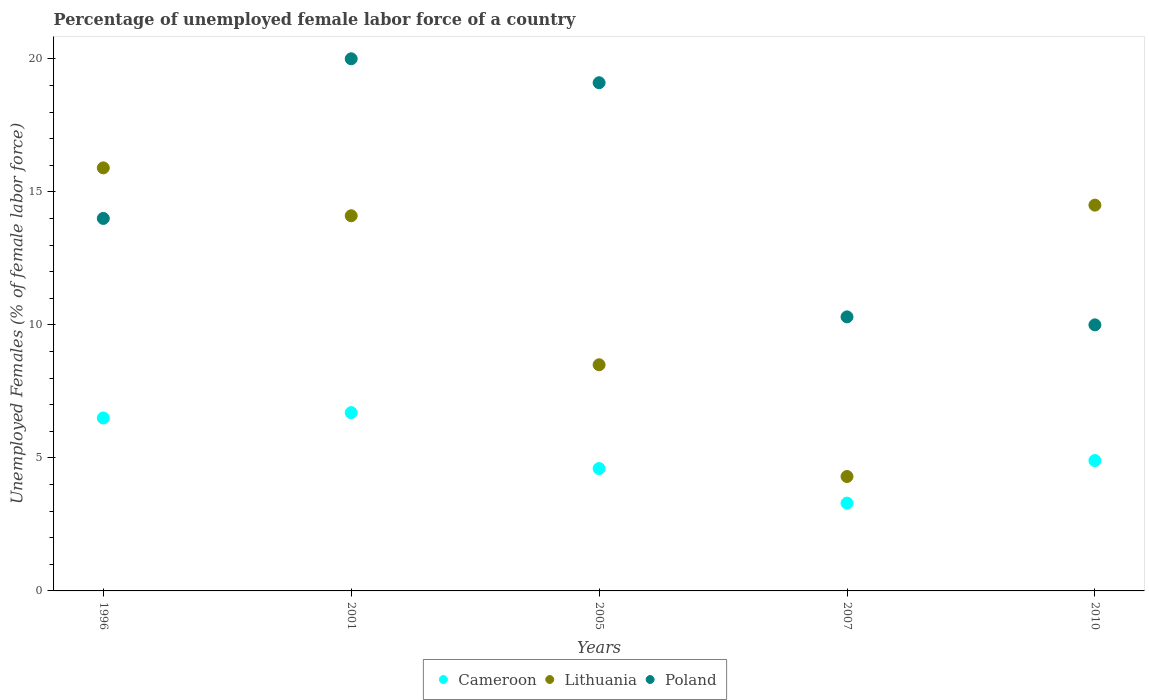How many different coloured dotlines are there?
Keep it short and to the point. 3. What is the percentage of unemployed female labor force in Poland in 1996?
Your answer should be compact. 14. Across all years, what is the maximum percentage of unemployed female labor force in Cameroon?
Keep it short and to the point. 6.7. Across all years, what is the minimum percentage of unemployed female labor force in Cameroon?
Keep it short and to the point. 3.3. In which year was the percentage of unemployed female labor force in Lithuania maximum?
Your answer should be very brief. 1996. In which year was the percentage of unemployed female labor force in Lithuania minimum?
Your answer should be very brief. 2007. What is the total percentage of unemployed female labor force in Poland in the graph?
Your response must be concise. 73.4. What is the difference between the percentage of unemployed female labor force in Poland in 1996 and that in 2007?
Provide a succinct answer. 3.7. What is the difference between the percentage of unemployed female labor force in Poland in 2005 and the percentage of unemployed female labor force in Cameroon in 2007?
Make the answer very short. 15.8. What is the average percentage of unemployed female labor force in Lithuania per year?
Your answer should be compact. 11.46. In the year 2005, what is the difference between the percentage of unemployed female labor force in Poland and percentage of unemployed female labor force in Lithuania?
Offer a very short reply. 10.6. What is the ratio of the percentage of unemployed female labor force in Lithuania in 2001 to that in 2010?
Your answer should be compact. 0.97. Is the percentage of unemployed female labor force in Poland in 2001 less than that in 2005?
Make the answer very short. No. What is the difference between the highest and the second highest percentage of unemployed female labor force in Lithuania?
Your answer should be very brief. 1.4. What is the difference between the highest and the lowest percentage of unemployed female labor force in Lithuania?
Provide a short and direct response. 11.6. In how many years, is the percentage of unemployed female labor force in Lithuania greater than the average percentage of unemployed female labor force in Lithuania taken over all years?
Your response must be concise. 3. Is the sum of the percentage of unemployed female labor force in Cameroon in 2001 and 2007 greater than the maximum percentage of unemployed female labor force in Poland across all years?
Offer a terse response. No. Is it the case that in every year, the sum of the percentage of unemployed female labor force in Poland and percentage of unemployed female labor force in Lithuania  is greater than the percentage of unemployed female labor force in Cameroon?
Your answer should be compact. Yes. Is the percentage of unemployed female labor force in Cameroon strictly greater than the percentage of unemployed female labor force in Poland over the years?
Offer a very short reply. No. How many dotlines are there?
Offer a terse response. 3. Does the graph contain any zero values?
Provide a succinct answer. No. Does the graph contain grids?
Provide a succinct answer. No. Where does the legend appear in the graph?
Offer a terse response. Bottom center. How are the legend labels stacked?
Offer a terse response. Horizontal. What is the title of the graph?
Provide a succinct answer. Percentage of unemployed female labor force of a country. What is the label or title of the X-axis?
Ensure brevity in your answer.  Years. What is the label or title of the Y-axis?
Provide a short and direct response. Unemployed Females (% of female labor force). What is the Unemployed Females (% of female labor force) in Lithuania in 1996?
Provide a short and direct response. 15.9. What is the Unemployed Females (% of female labor force) of Poland in 1996?
Provide a succinct answer. 14. What is the Unemployed Females (% of female labor force) of Cameroon in 2001?
Offer a terse response. 6.7. What is the Unemployed Females (% of female labor force) of Lithuania in 2001?
Offer a terse response. 14.1. What is the Unemployed Females (% of female labor force) in Cameroon in 2005?
Keep it short and to the point. 4.6. What is the Unemployed Females (% of female labor force) of Poland in 2005?
Make the answer very short. 19.1. What is the Unemployed Females (% of female labor force) of Cameroon in 2007?
Give a very brief answer. 3.3. What is the Unemployed Females (% of female labor force) in Lithuania in 2007?
Ensure brevity in your answer.  4.3. What is the Unemployed Females (% of female labor force) in Poland in 2007?
Provide a succinct answer. 10.3. What is the Unemployed Females (% of female labor force) of Cameroon in 2010?
Your response must be concise. 4.9. What is the Unemployed Females (% of female labor force) in Lithuania in 2010?
Your response must be concise. 14.5. What is the Unemployed Females (% of female labor force) of Poland in 2010?
Your answer should be compact. 10. Across all years, what is the maximum Unemployed Females (% of female labor force) of Cameroon?
Ensure brevity in your answer.  6.7. Across all years, what is the maximum Unemployed Females (% of female labor force) of Lithuania?
Offer a very short reply. 15.9. Across all years, what is the minimum Unemployed Females (% of female labor force) in Cameroon?
Ensure brevity in your answer.  3.3. Across all years, what is the minimum Unemployed Females (% of female labor force) in Lithuania?
Offer a terse response. 4.3. Across all years, what is the minimum Unemployed Females (% of female labor force) in Poland?
Your answer should be compact. 10. What is the total Unemployed Females (% of female labor force) in Cameroon in the graph?
Offer a terse response. 26. What is the total Unemployed Females (% of female labor force) of Lithuania in the graph?
Offer a terse response. 57.3. What is the total Unemployed Females (% of female labor force) in Poland in the graph?
Offer a very short reply. 73.4. What is the difference between the Unemployed Females (% of female labor force) of Cameroon in 1996 and that in 2001?
Keep it short and to the point. -0.2. What is the difference between the Unemployed Females (% of female labor force) in Poland in 1996 and that in 2001?
Your answer should be very brief. -6. What is the difference between the Unemployed Females (% of female labor force) in Lithuania in 1996 and that in 2005?
Give a very brief answer. 7.4. What is the difference between the Unemployed Females (% of female labor force) in Poland in 1996 and that in 2005?
Your response must be concise. -5.1. What is the difference between the Unemployed Females (% of female labor force) in Lithuania in 1996 and that in 2007?
Your answer should be compact. 11.6. What is the difference between the Unemployed Females (% of female labor force) of Poland in 1996 and that in 2007?
Ensure brevity in your answer.  3.7. What is the difference between the Unemployed Females (% of female labor force) of Cameroon in 1996 and that in 2010?
Keep it short and to the point. 1.6. What is the difference between the Unemployed Females (% of female labor force) of Lithuania in 2001 and that in 2005?
Make the answer very short. 5.6. What is the difference between the Unemployed Females (% of female labor force) in Lithuania in 2001 and that in 2010?
Offer a very short reply. -0.4. What is the difference between the Unemployed Females (% of female labor force) of Poland in 2001 and that in 2010?
Make the answer very short. 10. What is the difference between the Unemployed Females (% of female labor force) in Cameroon in 2005 and that in 2007?
Offer a terse response. 1.3. What is the difference between the Unemployed Females (% of female labor force) in Lithuania in 2005 and that in 2007?
Keep it short and to the point. 4.2. What is the difference between the Unemployed Females (% of female labor force) in Lithuania in 2005 and that in 2010?
Your answer should be very brief. -6. What is the difference between the Unemployed Females (% of female labor force) of Poland in 2005 and that in 2010?
Keep it short and to the point. 9.1. What is the difference between the Unemployed Females (% of female labor force) in Poland in 2007 and that in 2010?
Your answer should be very brief. 0.3. What is the difference between the Unemployed Females (% of female labor force) of Cameroon in 1996 and the Unemployed Females (% of female labor force) of Lithuania in 2001?
Offer a very short reply. -7.6. What is the difference between the Unemployed Females (% of female labor force) of Cameroon in 1996 and the Unemployed Females (% of female labor force) of Poland in 2001?
Ensure brevity in your answer.  -13.5. What is the difference between the Unemployed Females (% of female labor force) in Cameroon in 1996 and the Unemployed Females (% of female labor force) in Lithuania in 2005?
Make the answer very short. -2. What is the difference between the Unemployed Females (% of female labor force) of Cameroon in 1996 and the Unemployed Females (% of female labor force) of Poland in 2007?
Ensure brevity in your answer.  -3.8. What is the difference between the Unemployed Females (% of female labor force) in Lithuania in 1996 and the Unemployed Females (% of female labor force) in Poland in 2010?
Provide a short and direct response. 5.9. What is the difference between the Unemployed Females (% of female labor force) of Cameroon in 2001 and the Unemployed Females (% of female labor force) of Poland in 2007?
Ensure brevity in your answer.  -3.6. What is the difference between the Unemployed Females (% of female labor force) of Cameroon in 2001 and the Unemployed Females (% of female labor force) of Poland in 2010?
Your answer should be compact. -3.3. What is the difference between the Unemployed Females (% of female labor force) in Cameroon in 2005 and the Unemployed Females (% of female labor force) in Poland in 2007?
Provide a short and direct response. -5.7. What is the difference between the Unemployed Females (% of female labor force) in Lithuania in 2005 and the Unemployed Females (% of female labor force) in Poland in 2007?
Your response must be concise. -1.8. What is the difference between the Unemployed Females (% of female labor force) of Cameroon in 2005 and the Unemployed Females (% of female labor force) of Lithuania in 2010?
Provide a short and direct response. -9.9. What is the difference between the Unemployed Females (% of female labor force) of Lithuania in 2007 and the Unemployed Females (% of female labor force) of Poland in 2010?
Your answer should be very brief. -5.7. What is the average Unemployed Females (% of female labor force) in Lithuania per year?
Your response must be concise. 11.46. What is the average Unemployed Females (% of female labor force) in Poland per year?
Offer a very short reply. 14.68. In the year 1996, what is the difference between the Unemployed Females (% of female labor force) of Cameroon and Unemployed Females (% of female labor force) of Lithuania?
Provide a succinct answer. -9.4. In the year 1996, what is the difference between the Unemployed Females (% of female labor force) of Lithuania and Unemployed Females (% of female labor force) of Poland?
Provide a succinct answer. 1.9. In the year 2007, what is the difference between the Unemployed Females (% of female labor force) in Lithuania and Unemployed Females (% of female labor force) in Poland?
Offer a very short reply. -6. In the year 2010, what is the difference between the Unemployed Females (% of female labor force) of Cameroon and Unemployed Females (% of female labor force) of Lithuania?
Your answer should be very brief. -9.6. In the year 2010, what is the difference between the Unemployed Females (% of female labor force) in Cameroon and Unemployed Females (% of female labor force) in Poland?
Keep it short and to the point. -5.1. What is the ratio of the Unemployed Females (% of female labor force) in Cameroon in 1996 to that in 2001?
Your response must be concise. 0.97. What is the ratio of the Unemployed Females (% of female labor force) of Lithuania in 1996 to that in 2001?
Offer a terse response. 1.13. What is the ratio of the Unemployed Females (% of female labor force) of Cameroon in 1996 to that in 2005?
Give a very brief answer. 1.41. What is the ratio of the Unemployed Females (% of female labor force) of Lithuania in 1996 to that in 2005?
Make the answer very short. 1.87. What is the ratio of the Unemployed Females (% of female labor force) in Poland in 1996 to that in 2005?
Give a very brief answer. 0.73. What is the ratio of the Unemployed Females (% of female labor force) of Cameroon in 1996 to that in 2007?
Make the answer very short. 1.97. What is the ratio of the Unemployed Females (% of female labor force) in Lithuania in 1996 to that in 2007?
Your response must be concise. 3.7. What is the ratio of the Unemployed Females (% of female labor force) of Poland in 1996 to that in 2007?
Your answer should be compact. 1.36. What is the ratio of the Unemployed Females (% of female labor force) of Cameroon in 1996 to that in 2010?
Provide a short and direct response. 1.33. What is the ratio of the Unemployed Females (% of female labor force) in Lithuania in 1996 to that in 2010?
Your answer should be compact. 1.1. What is the ratio of the Unemployed Females (% of female labor force) of Cameroon in 2001 to that in 2005?
Your response must be concise. 1.46. What is the ratio of the Unemployed Females (% of female labor force) in Lithuania in 2001 to that in 2005?
Provide a succinct answer. 1.66. What is the ratio of the Unemployed Females (% of female labor force) in Poland in 2001 to that in 2005?
Make the answer very short. 1.05. What is the ratio of the Unemployed Females (% of female labor force) of Cameroon in 2001 to that in 2007?
Provide a succinct answer. 2.03. What is the ratio of the Unemployed Females (% of female labor force) in Lithuania in 2001 to that in 2007?
Provide a short and direct response. 3.28. What is the ratio of the Unemployed Females (% of female labor force) in Poland in 2001 to that in 2007?
Your answer should be compact. 1.94. What is the ratio of the Unemployed Females (% of female labor force) in Cameroon in 2001 to that in 2010?
Ensure brevity in your answer.  1.37. What is the ratio of the Unemployed Females (% of female labor force) in Lithuania in 2001 to that in 2010?
Offer a terse response. 0.97. What is the ratio of the Unemployed Females (% of female labor force) of Poland in 2001 to that in 2010?
Your response must be concise. 2. What is the ratio of the Unemployed Females (% of female labor force) of Cameroon in 2005 to that in 2007?
Your answer should be compact. 1.39. What is the ratio of the Unemployed Females (% of female labor force) in Lithuania in 2005 to that in 2007?
Your answer should be very brief. 1.98. What is the ratio of the Unemployed Females (% of female labor force) in Poland in 2005 to that in 2007?
Your response must be concise. 1.85. What is the ratio of the Unemployed Females (% of female labor force) of Cameroon in 2005 to that in 2010?
Provide a short and direct response. 0.94. What is the ratio of the Unemployed Females (% of female labor force) in Lithuania in 2005 to that in 2010?
Ensure brevity in your answer.  0.59. What is the ratio of the Unemployed Females (% of female labor force) in Poland in 2005 to that in 2010?
Make the answer very short. 1.91. What is the ratio of the Unemployed Females (% of female labor force) in Cameroon in 2007 to that in 2010?
Provide a succinct answer. 0.67. What is the ratio of the Unemployed Females (% of female labor force) in Lithuania in 2007 to that in 2010?
Your answer should be compact. 0.3. What is the difference between the highest and the second highest Unemployed Females (% of female labor force) of Cameroon?
Ensure brevity in your answer.  0.2. What is the difference between the highest and the second highest Unemployed Females (% of female labor force) in Poland?
Offer a terse response. 0.9. What is the difference between the highest and the lowest Unemployed Females (% of female labor force) in Cameroon?
Keep it short and to the point. 3.4. 